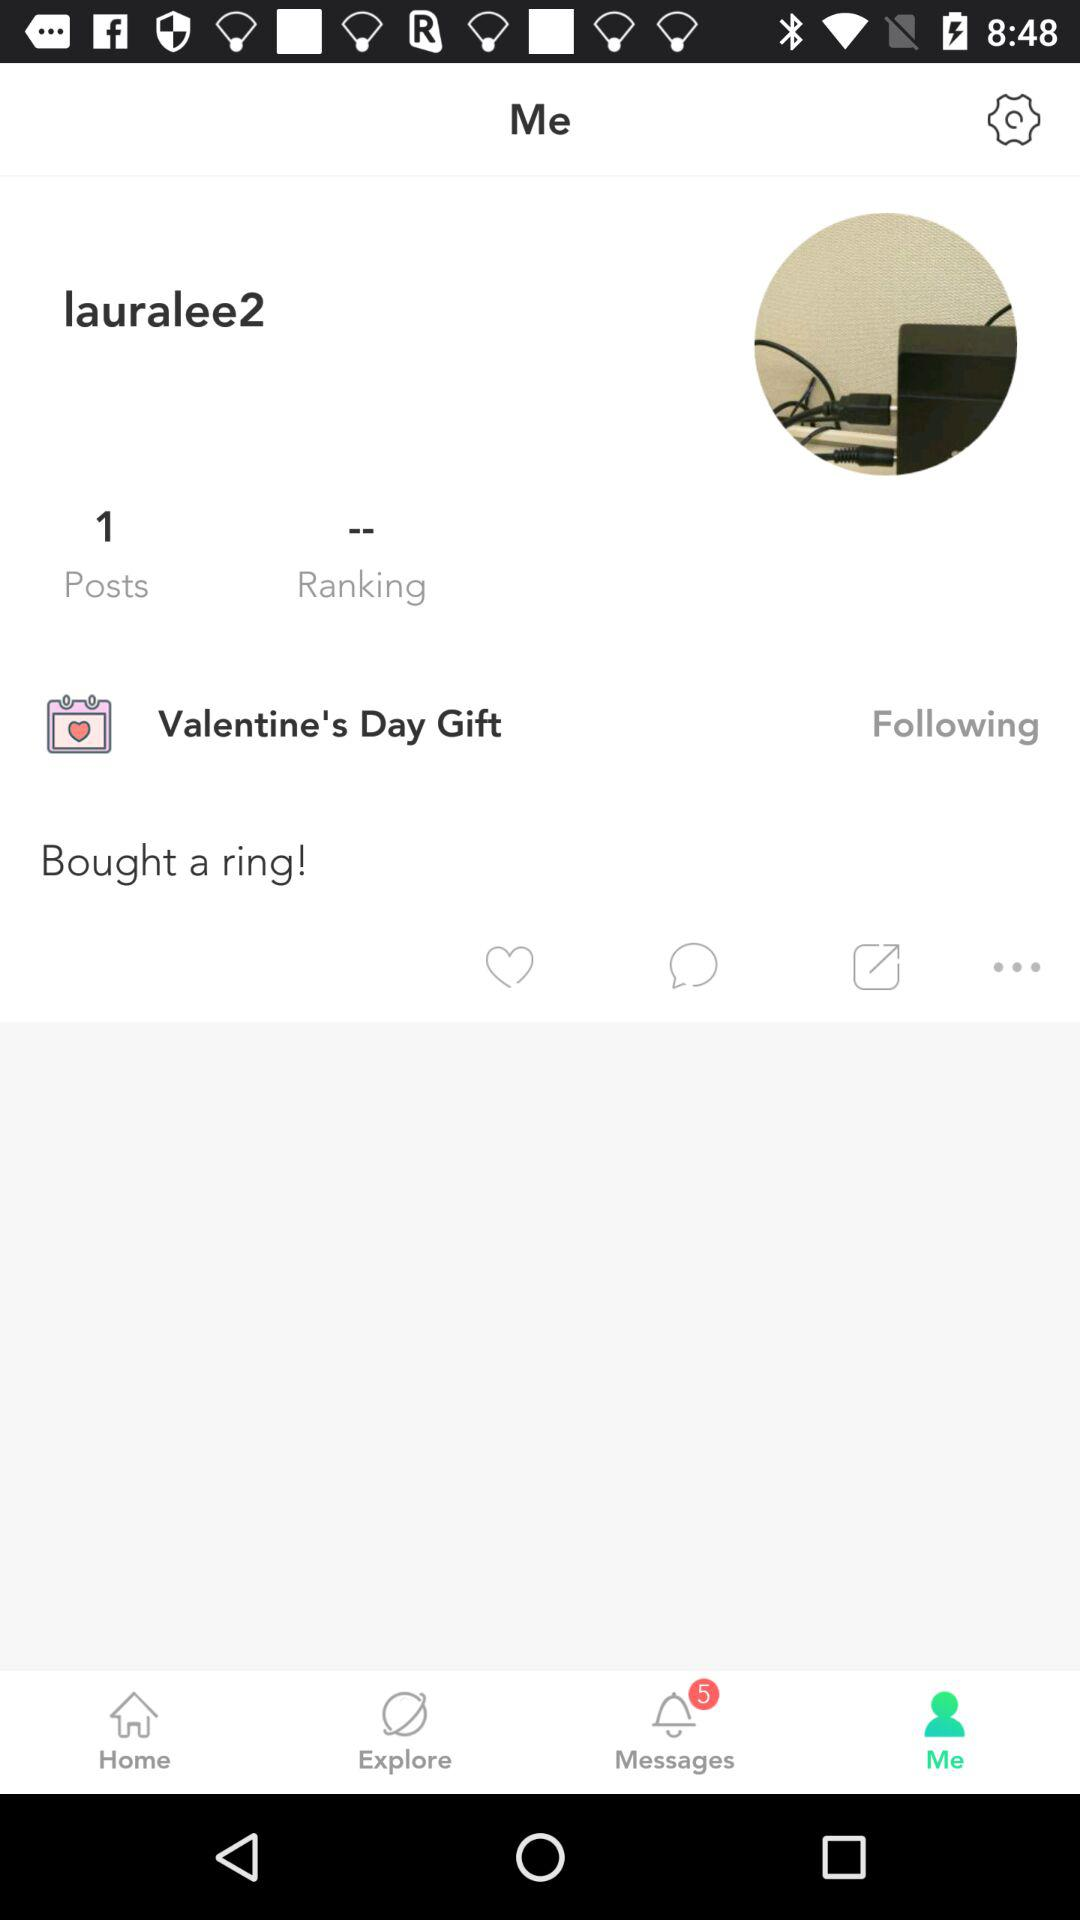How many more posts than rankings are there?
Answer the question using a single word or phrase. 1 